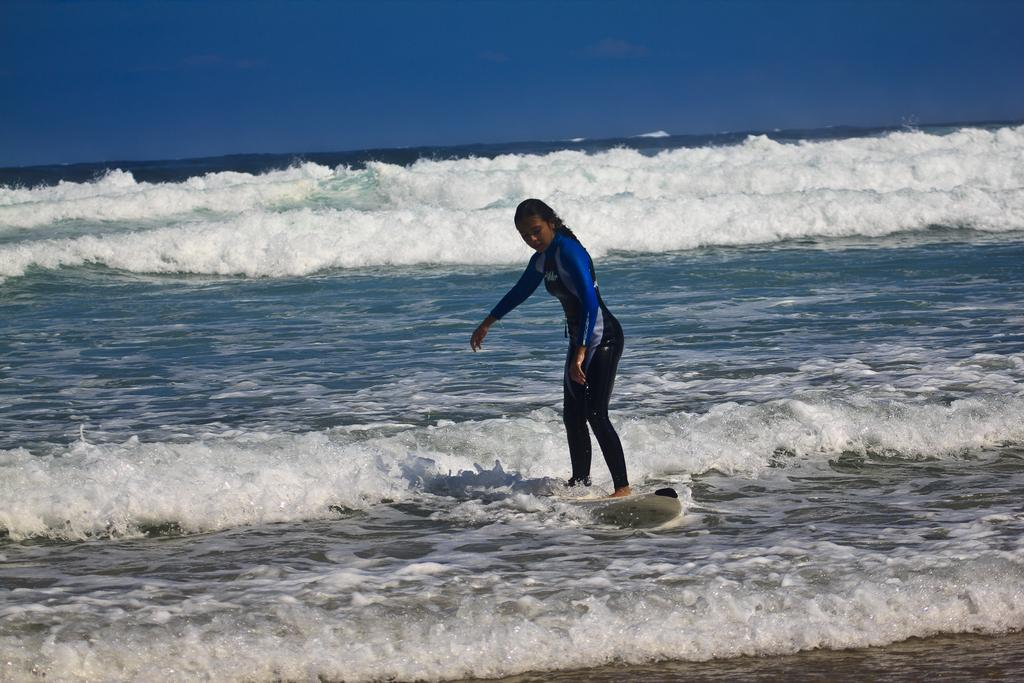Who is the main subject in the image? There is a woman in the image. What is the woman doing in the image? The woman is surfing on the water. What can be seen at the top of the image? The sky is visible at the top of the image. What type of environment is depicted in the image? There is water and sand in the image, suggesting a beach setting. What type of verse can be heard being recited by the woman in the image? There is no indication in the image that the woman is reciting any verse, so it cannot be determined from the picture. 